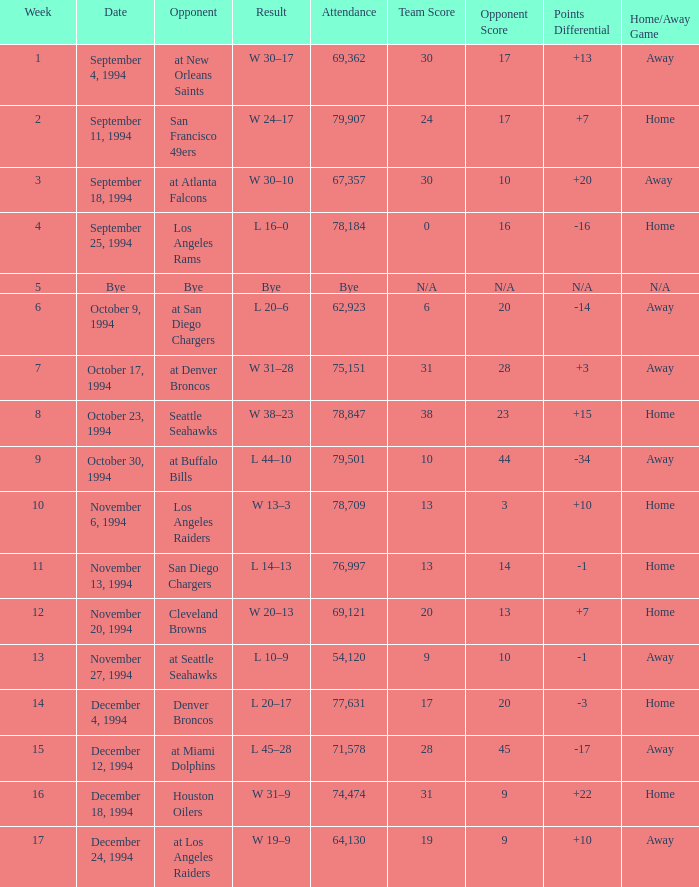What was the score of the Chiefs November 27, 1994 game? L 10–9. 